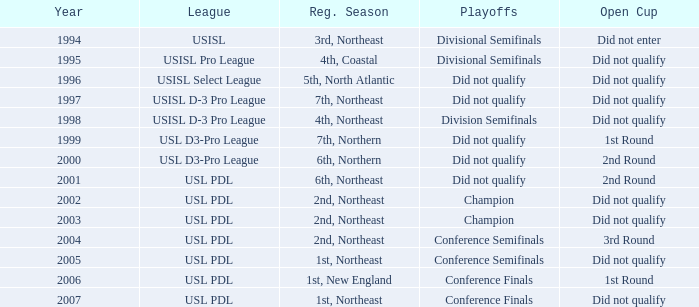Can you give me this table as a dict? {'header': ['Year', 'League', 'Reg. Season', 'Playoffs', 'Open Cup'], 'rows': [['1994', 'USISL', '3rd, Northeast', 'Divisional Semifinals', 'Did not enter'], ['1995', 'USISL Pro League', '4th, Coastal', 'Divisional Semifinals', 'Did not qualify'], ['1996', 'USISL Select League', '5th, North Atlantic', 'Did not qualify', 'Did not qualify'], ['1997', 'USISL D-3 Pro League', '7th, Northeast', 'Did not qualify', 'Did not qualify'], ['1998', 'USISL D-3 Pro League', '4th, Northeast', 'Division Semifinals', 'Did not qualify'], ['1999', 'USL D3-Pro League', '7th, Northern', 'Did not qualify', '1st Round'], ['2000', 'USL D3-Pro League', '6th, Northern', 'Did not qualify', '2nd Round'], ['2001', 'USL PDL', '6th, Northeast', 'Did not qualify', '2nd Round'], ['2002', 'USL PDL', '2nd, Northeast', 'Champion', 'Did not qualify'], ['2003', 'USL PDL', '2nd, Northeast', 'Champion', 'Did not qualify'], ['2004', 'USL PDL', '2nd, Northeast', 'Conference Semifinals', '3rd Round'], ['2005', 'USL PDL', '1st, Northeast', 'Conference Semifinals', 'Did not qualify'], ['2006', 'USL PDL', '1st, New England', 'Conference Finals', '1st Round'], ['2007', 'USL PDL', '1st, Northeast', 'Conference Finals', 'Did not qualify']]} What are the playoffs called for the usisl select league? Did not qualify. 